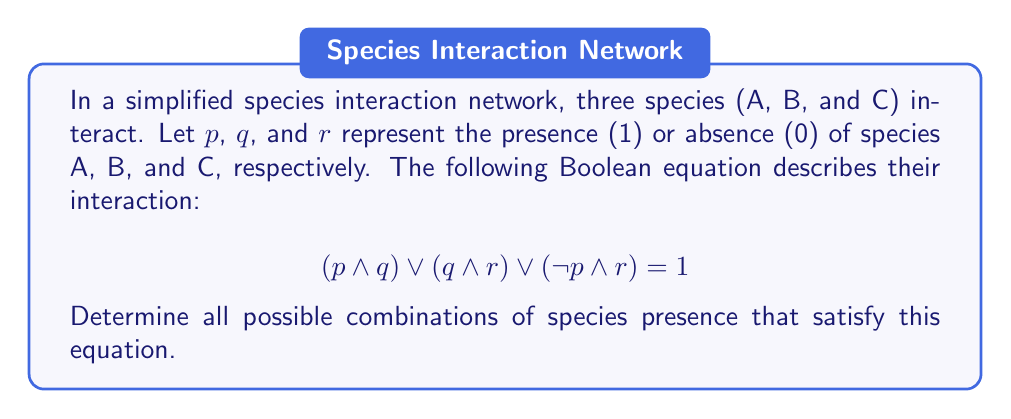Can you solve this math problem? Let's approach this step-by-step:

1) We need to evaluate the equation for all possible combinations of $p$, $q$, and $r$. There are 8 possible combinations (2^3).

2) Let's create a truth table:

   $p$ | $q$ | $r$ | $(p \land q)$ | $(q \land r)$ | $(\neg p \land r)$ | Result
   ---|---|---|-------------|-------------|-----------------|-------
   0 | 0 | 0 |     0       |     0       |       0         |   0
   0 | 0 | 1 |     0       |     0       |       1         |   1
   0 | 1 | 0 |     0       |     0       |       0         |   0
   0 | 1 | 1 |     0       |     1       |       1         |   1
   1 | 0 | 0 |     0       |     0       |       0         |   0
   1 | 0 | 1 |     0       |     0       |       0         |   0
   1 | 1 | 0 |     1       |     0       |       0         |   1
   1 | 1 | 1 |     1       |     1       |       0         |   1

3) The equation is satisfied (equals 1) when:
   - $p = 0$, $q = 0$, $r = 1$
   - $p = 0$, $q = 1$, $r = 1$
   - $p = 1$, $q = 1$, $r = 0$
   - $p = 1$, $q = 1$, $r = 1$

4) Interpreting these results in terms of species presence:
   - Species C present alone
   - Species B and C present
   - Species A and B present
   - All three species present
Answer: $(0,0,1)$, $(0,1,1)$, $(1,1,0)$, $(1,1,1)$ 